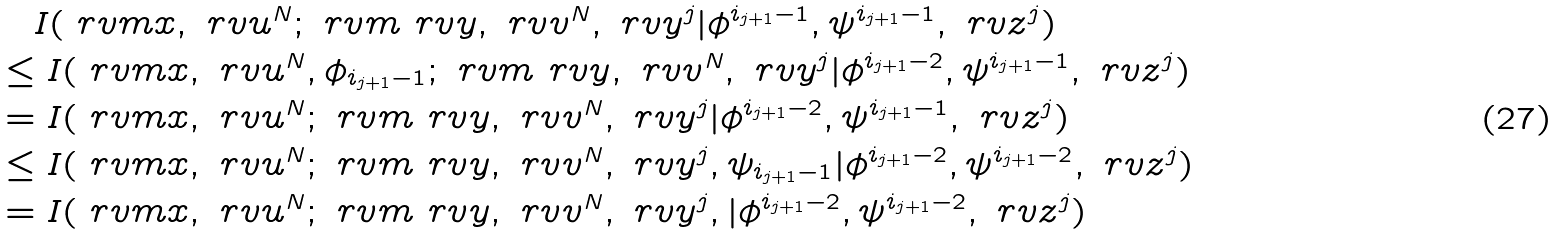<formula> <loc_0><loc_0><loc_500><loc_500>& \quad I ( \ r v m x , \ r v u ^ { N } ; \ r v m _ { \ } r v y , \ r v v ^ { N } , \ r v y ^ { j } | \phi ^ { i _ { j + 1 } - 1 } , \psi ^ { i _ { j + 1 } - 1 } , \ r v z ^ { j } ) \\ & \leq I ( \ r v m x , \ r v u ^ { N } , \phi _ { i _ { j + 1 } - 1 } ; \ r v m _ { \ } r v y , \ r v v ^ { N } , \ r v y ^ { j } | \phi ^ { i _ { j + 1 } - 2 } , \psi ^ { i _ { j + 1 } - 1 } , \ r v z ^ { j } ) \\ & = I ( \ r v m x , \ r v u ^ { N } ; \ r v m _ { \ } r v y , \ r v v ^ { N } , \ r v y ^ { j } | \phi ^ { i _ { j + 1 } - 2 } , \psi ^ { i _ { j + 1 } - 1 } , \ r v z ^ { j } ) \\ & \leq I ( \ r v m x , \ r v u ^ { N } ; \ r v m _ { \ } r v y , \ r v v ^ { N } , \ r v y ^ { j } , \psi _ { i _ { j + 1 } - 1 } | \phi ^ { i _ { j + 1 } - 2 } , \psi ^ { i _ { j + 1 } - 2 } , \ r v z ^ { j } ) \\ & = I ( \ r v m x , \ r v u ^ { N } ; \ r v m _ { \ } r v y , \ r v v ^ { N } , \ r v y ^ { j } , | \phi ^ { i _ { j + 1 } - 2 } , \psi ^ { i _ { j + 1 } - 2 } , \ r v z ^ { j } )</formula> 